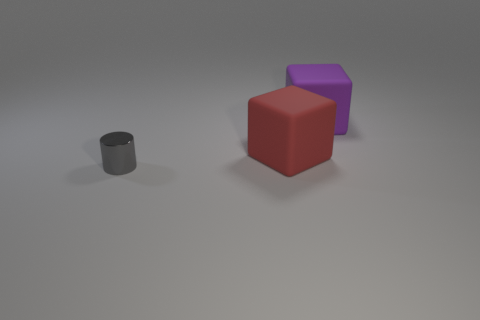What number of things are small gray objects or big purple rubber things that are behind the red object?
Ensure brevity in your answer.  2. What size is the purple thing that is the same shape as the red rubber thing?
Make the answer very short. Large. Is there any other thing that has the same size as the purple rubber block?
Your answer should be very brief. Yes. There is a big purple rubber thing; are there any purple blocks in front of it?
Keep it short and to the point. No. There is a rubber cube that is left of the purple rubber thing; does it have the same color as the cylinder to the left of the purple rubber block?
Offer a terse response. No. Is there another red object of the same shape as the tiny thing?
Offer a terse response. No. How many other things are there of the same color as the metallic object?
Provide a succinct answer. 0. There is a big object left of the large block behind the cube that is left of the large purple rubber thing; what is its color?
Provide a short and direct response. Red. Are there the same number of big purple objects to the left of the large purple object and small cylinders?
Ensure brevity in your answer.  No. Does the matte object that is to the right of the red object have the same size as the cylinder?
Provide a short and direct response. No. 